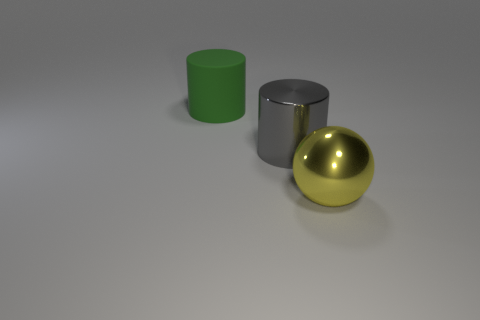Add 2 tiny red matte cubes. How many objects exist? 5 Subtract all cylinders. How many objects are left? 1 Subtract 0 purple balls. How many objects are left? 3 Subtract all big yellow metal things. Subtract all gray cylinders. How many objects are left? 1 Add 3 large green cylinders. How many large green cylinders are left? 4 Add 3 green matte things. How many green matte things exist? 4 